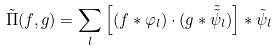<formula> <loc_0><loc_0><loc_500><loc_500>\tilde { \Pi } ( f , g ) = \sum _ { l } \left [ ( f \ast \varphi _ { l } ) \cdot ( g \ast \tilde { \tilde { \psi } } _ { l } ) \right ] \ast \tilde { \psi } _ { l }</formula> 